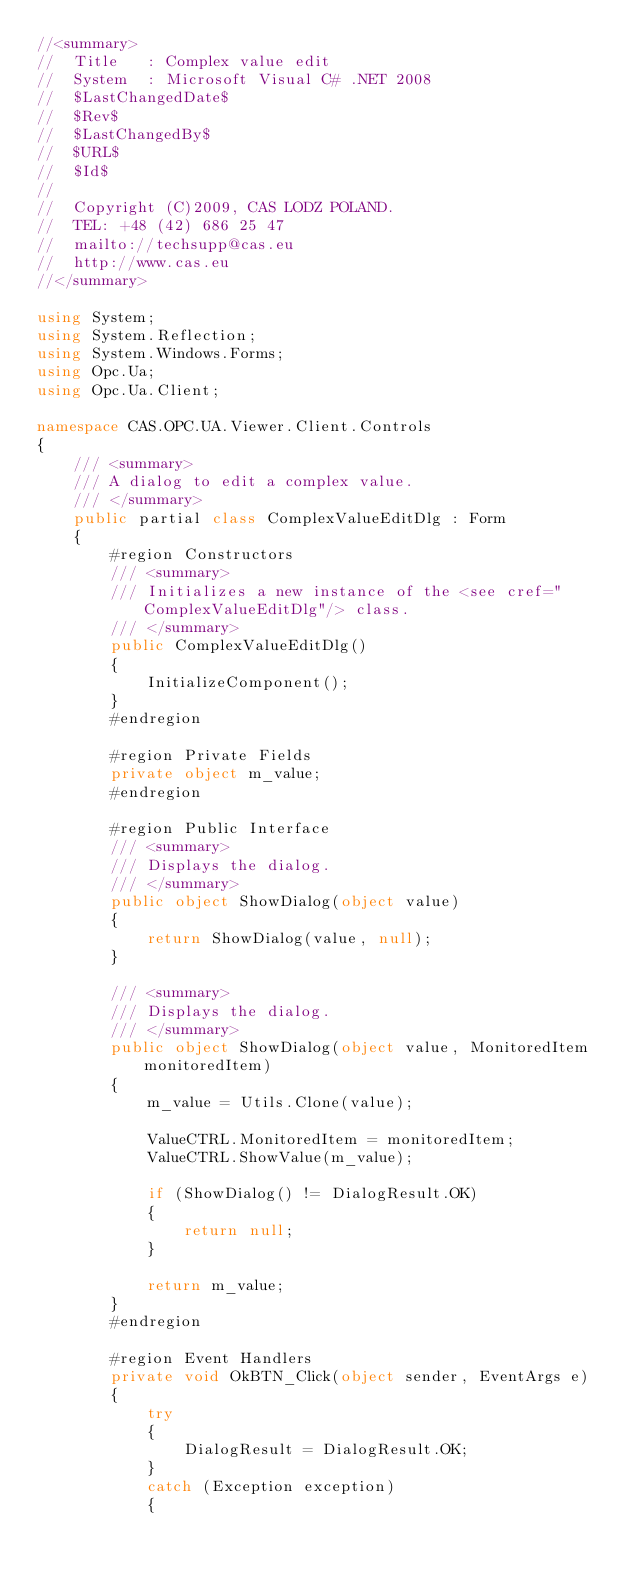<code> <loc_0><loc_0><loc_500><loc_500><_C#_>//<summary>
//  Title   : Complex value edit
//  System  : Microsoft Visual C# .NET 2008
//  $LastChangedDate$
//  $Rev$
//  $LastChangedBy$
//  $URL$
//  $Id$
//
//  Copyright (C)2009, CAS LODZ POLAND.
//  TEL: +48 (42) 686 25 47
//  mailto://techsupp@cas.eu
//  http://www.cas.eu
//</summary>

using System;
using System.Reflection;
using System.Windows.Forms;
using Opc.Ua;
using Opc.Ua.Client;

namespace CAS.OPC.UA.Viewer.Client.Controls
{
    /// <summary>
    /// A dialog to edit a complex value.
    /// </summary>
    public partial class ComplexValueEditDlg : Form
    {
        #region Constructors
        /// <summary>
        /// Initializes a new instance of the <see cref="ComplexValueEditDlg"/> class.
        /// </summary>
        public ComplexValueEditDlg()
        {
            InitializeComponent();
        }
        #endregion
        
        #region Private Fields
        private object m_value;
        #endregion
        
        #region Public Interface
        /// <summary>
        /// Displays the dialog.
        /// </summary>
        public object ShowDialog(object value)
        {
            return ShowDialog(value, null);
        }

        /// <summary>
        /// Displays the dialog.
        /// </summary>
        public object ShowDialog(object value, MonitoredItem monitoredItem)
        {
            m_value = Utils.Clone(value);

            ValueCTRL.MonitoredItem = monitoredItem;
            ValueCTRL.ShowValue(m_value);

            if (ShowDialog() != DialogResult.OK)
            {
                return null;
            }

            return m_value;
        }
        #endregion
        
        #region Event Handlers
        private void OkBTN_Click(object sender, EventArgs e)
        {        
            try
            {
                DialogResult = DialogResult.OK;
            }
            catch (Exception exception)
            {</code> 